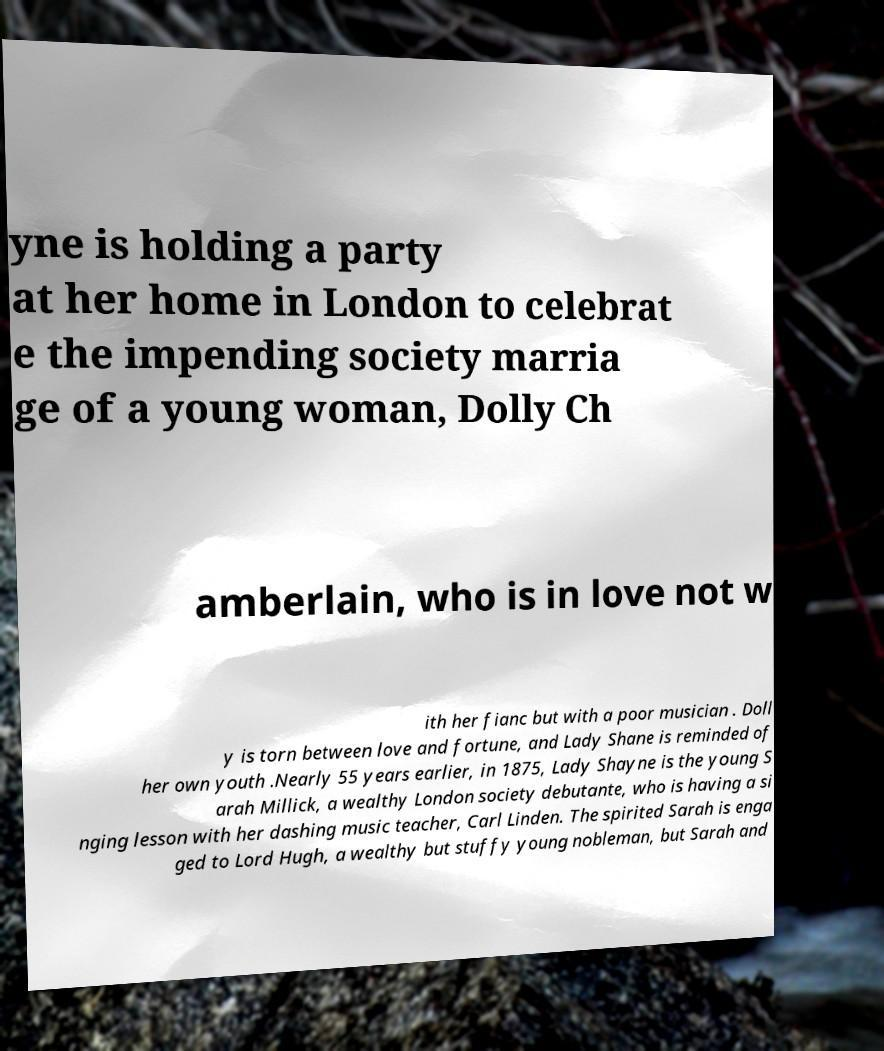Can you accurately transcribe the text from the provided image for me? yne is holding a party at her home in London to celebrat e the impending society marria ge of a young woman, Dolly Ch amberlain, who is in love not w ith her fianc but with a poor musician . Doll y is torn between love and fortune, and Lady Shane is reminded of her own youth .Nearly 55 years earlier, in 1875, Lady Shayne is the young S arah Millick, a wealthy London society debutante, who is having a si nging lesson with her dashing music teacher, Carl Linden. The spirited Sarah is enga ged to Lord Hugh, a wealthy but stuffy young nobleman, but Sarah and 